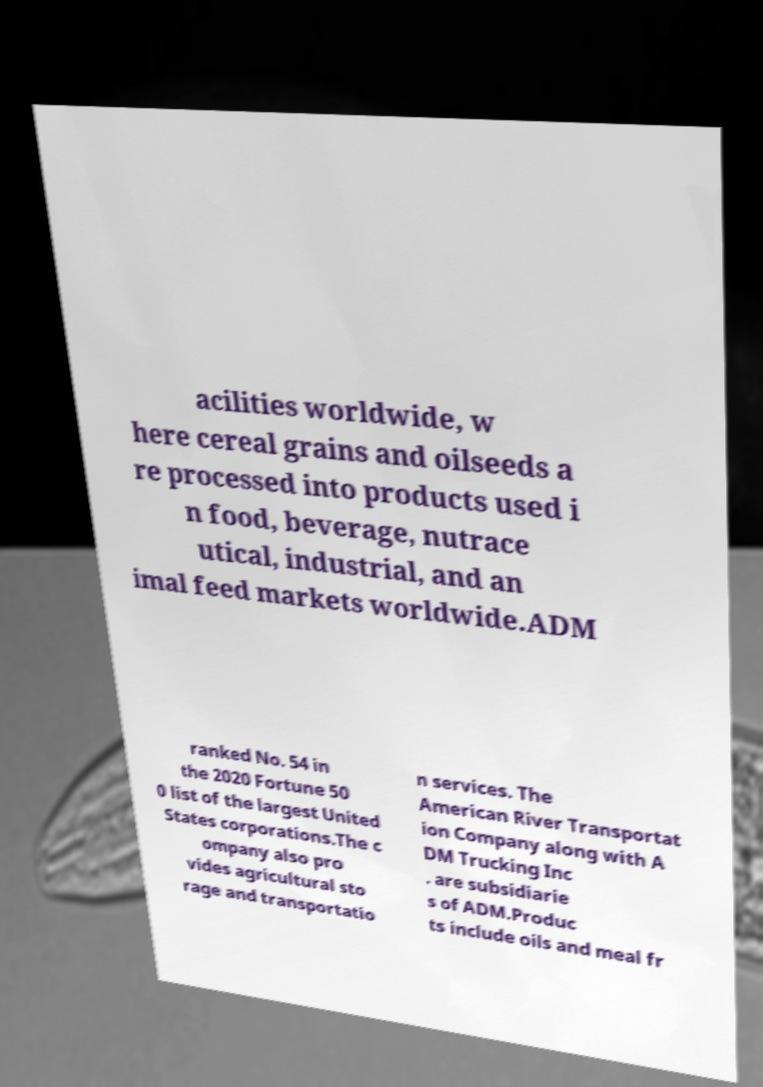Can you read and provide the text displayed in the image?This photo seems to have some interesting text. Can you extract and type it out for me? acilities worldwide, w here cereal grains and oilseeds a re processed into products used i n food, beverage, nutrace utical, industrial, and an imal feed markets worldwide.ADM ranked No. 54 in the 2020 Fortune 50 0 list of the largest United States corporations.The c ompany also pro vides agricultural sto rage and transportatio n services. The American River Transportat ion Company along with A DM Trucking Inc . are subsidiarie s of ADM.Produc ts include oils and meal fr 